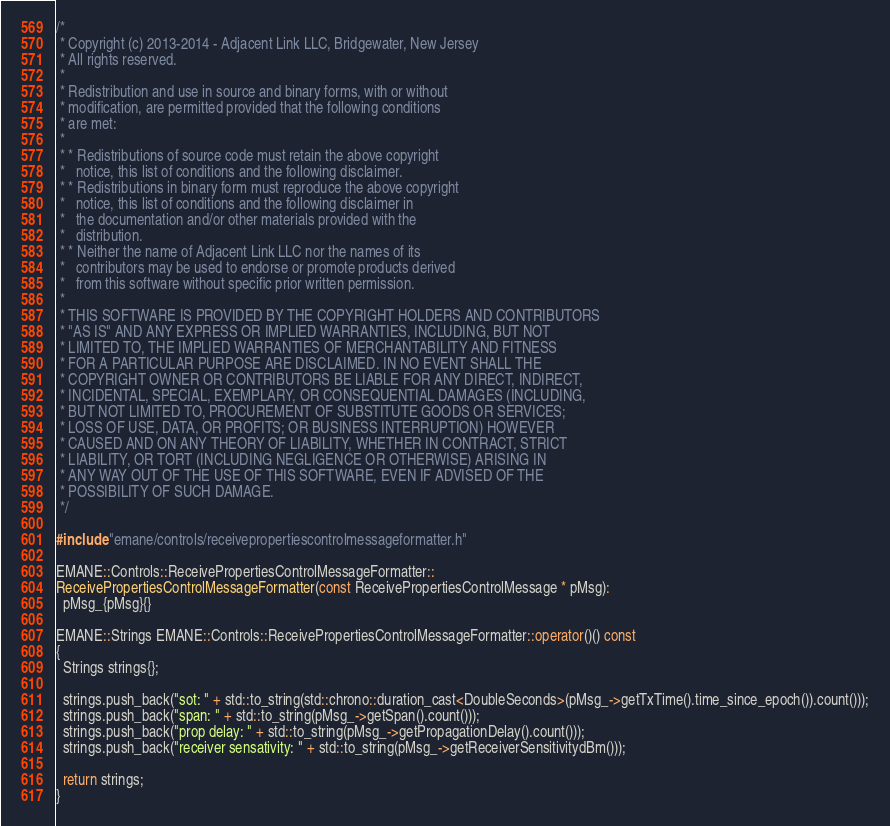<code> <loc_0><loc_0><loc_500><loc_500><_C++_>/*
 * Copyright (c) 2013-2014 - Adjacent Link LLC, Bridgewater, New Jersey
 * All rights reserved.
 *
 * Redistribution and use in source and binary forms, with or without
 * modification, are permitted provided that the following conditions
 * are met:
 *
 * * Redistributions of source code must retain the above copyright
 *   notice, this list of conditions and the following disclaimer.
 * * Redistributions in binary form must reproduce the above copyright
 *   notice, this list of conditions and the following disclaimer in
 *   the documentation and/or other materials provided with the
 *   distribution.
 * * Neither the name of Adjacent Link LLC nor the names of its
 *   contributors may be used to endorse or promote products derived
 *   from this software without specific prior written permission.
 *
 * THIS SOFTWARE IS PROVIDED BY THE COPYRIGHT HOLDERS AND CONTRIBUTORS
 * "AS IS" AND ANY EXPRESS OR IMPLIED WARRANTIES, INCLUDING, BUT NOT
 * LIMITED TO, THE IMPLIED WARRANTIES OF MERCHANTABILITY AND FITNESS
 * FOR A PARTICULAR PURPOSE ARE DISCLAIMED. IN NO EVENT SHALL THE
 * COPYRIGHT OWNER OR CONTRIBUTORS BE LIABLE FOR ANY DIRECT, INDIRECT,
 * INCIDENTAL, SPECIAL, EXEMPLARY, OR CONSEQUENTIAL DAMAGES (INCLUDING,
 * BUT NOT LIMITED TO, PROCUREMENT OF SUBSTITUTE GOODS OR SERVICES;
 * LOSS OF USE, DATA, OR PROFITS; OR BUSINESS INTERRUPTION) HOWEVER
 * CAUSED AND ON ANY THEORY OF LIABILITY, WHETHER IN CONTRACT, STRICT
 * LIABILITY, OR TORT (INCLUDING NEGLIGENCE OR OTHERWISE) ARISING IN
 * ANY WAY OUT OF THE USE OF THIS SOFTWARE, EVEN IF ADVISED OF THE
 * POSSIBILITY OF SUCH DAMAGE.
 */

#include "emane/controls/receivepropertiescontrolmessageformatter.h"

EMANE::Controls::ReceivePropertiesControlMessageFormatter::
ReceivePropertiesControlMessageFormatter(const ReceivePropertiesControlMessage * pMsg):
  pMsg_{pMsg}{}

EMANE::Strings EMANE::Controls::ReceivePropertiesControlMessageFormatter::operator()() const
{
  Strings strings{};
  
  strings.push_back("sot: " + std::to_string(std::chrono::duration_cast<DoubleSeconds>(pMsg_->getTxTime().time_since_epoch()).count()));
  strings.push_back("span: " + std::to_string(pMsg_->getSpan().count()));
  strings.push_back("prop delay: " + std::to_string(pMsg_->getPropagationDelay().count()));
  strings.push_back("receiver sensativity: " + std::to_string(pMsg_->getReceiverSensitivitydBm()));
  
  return strings;
}
</code> 